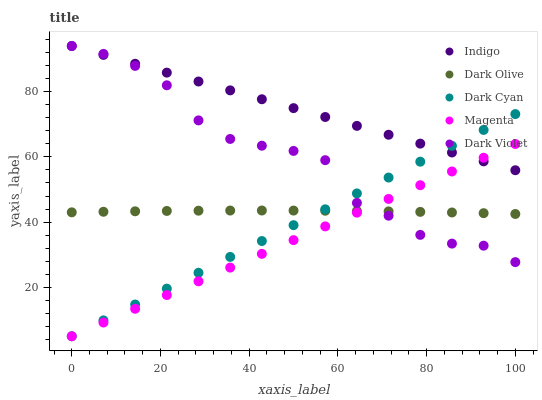Does Magenta have the minimum area under the curve?
Answer yes or no. Yes. Does Indigo have the maximum area under the curve?
Answer yes or no. Yes. Does Dark Olive have the minimum area under the curve?
Answer yes or no. No. Does Dark Olive have the maximum area under the curve?
Answer yes or no. No. Is Magenta the smoothest?
Answer yes or no. Yes. Is Dark Violet the roughest?
Answer yes or no. Yes. Is Dark Olive the smoothest?
Answer yes or no. No. Is Dark Olive the roughest?
Answer yes or no. No. Does Dark Cyan have the lowest value?
Answer yes or no. Yes. Does Dark Olive have the lowest value?
Answer yes or no. No. Does Dark Violet have the highest value?
Answer yes or no. Yes. Does Magenta have the highest value?
Answer yes or no. No. Is Dark Olive less than Indigo?
Answer yes or no. Yes. Is Indigo greater than Dark Olive?
Answer yes or no. Yes. Does Magenta intersect Indigo?
Answer yes or no. Yes. Is Magenta less than Indigo?
Answer yes or no. No. Is Magenta greater than Indigo?
Answer yes or no. No. Does Dark Olive intersect Indigo?
Answer yes or no. No. 